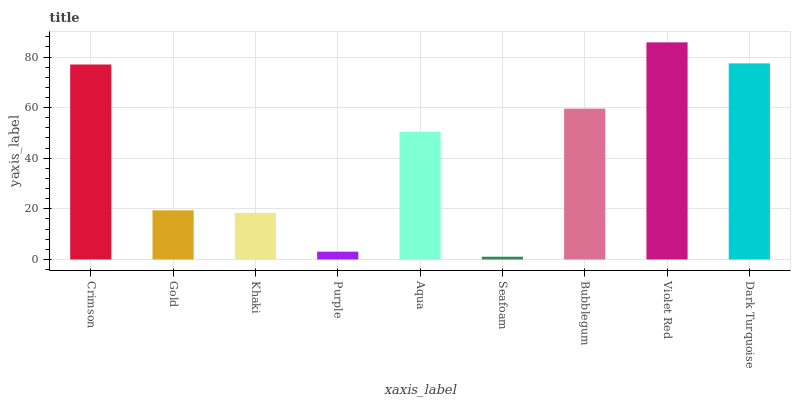Is Seafoam the minimum?
Answer yes or no. Yes. Is Violet Red the maximum?
Answer yes or no. Yes. Is Gold the minimum?
Answer yes or no. No. Is Gold the maximum?
Answer yes or no. No. Is Crimson greater than Gold?
Answer yes or no. Yes. Is Gold less than Crimson?
Answer yes or no. Yes. Is Gold greater than Crimson?
Answer yes or no. No. Is Crimson less than Gold?
Answer yes or no. No. Is Aqua the high median?
Answer yes or no. Yes. Is Aqua the low median?
Answer yes or no. Yes. Is Khaki the high median?
Answer yes or no. No. Is Bubblegum the low median?
Answer yes or no. No. 